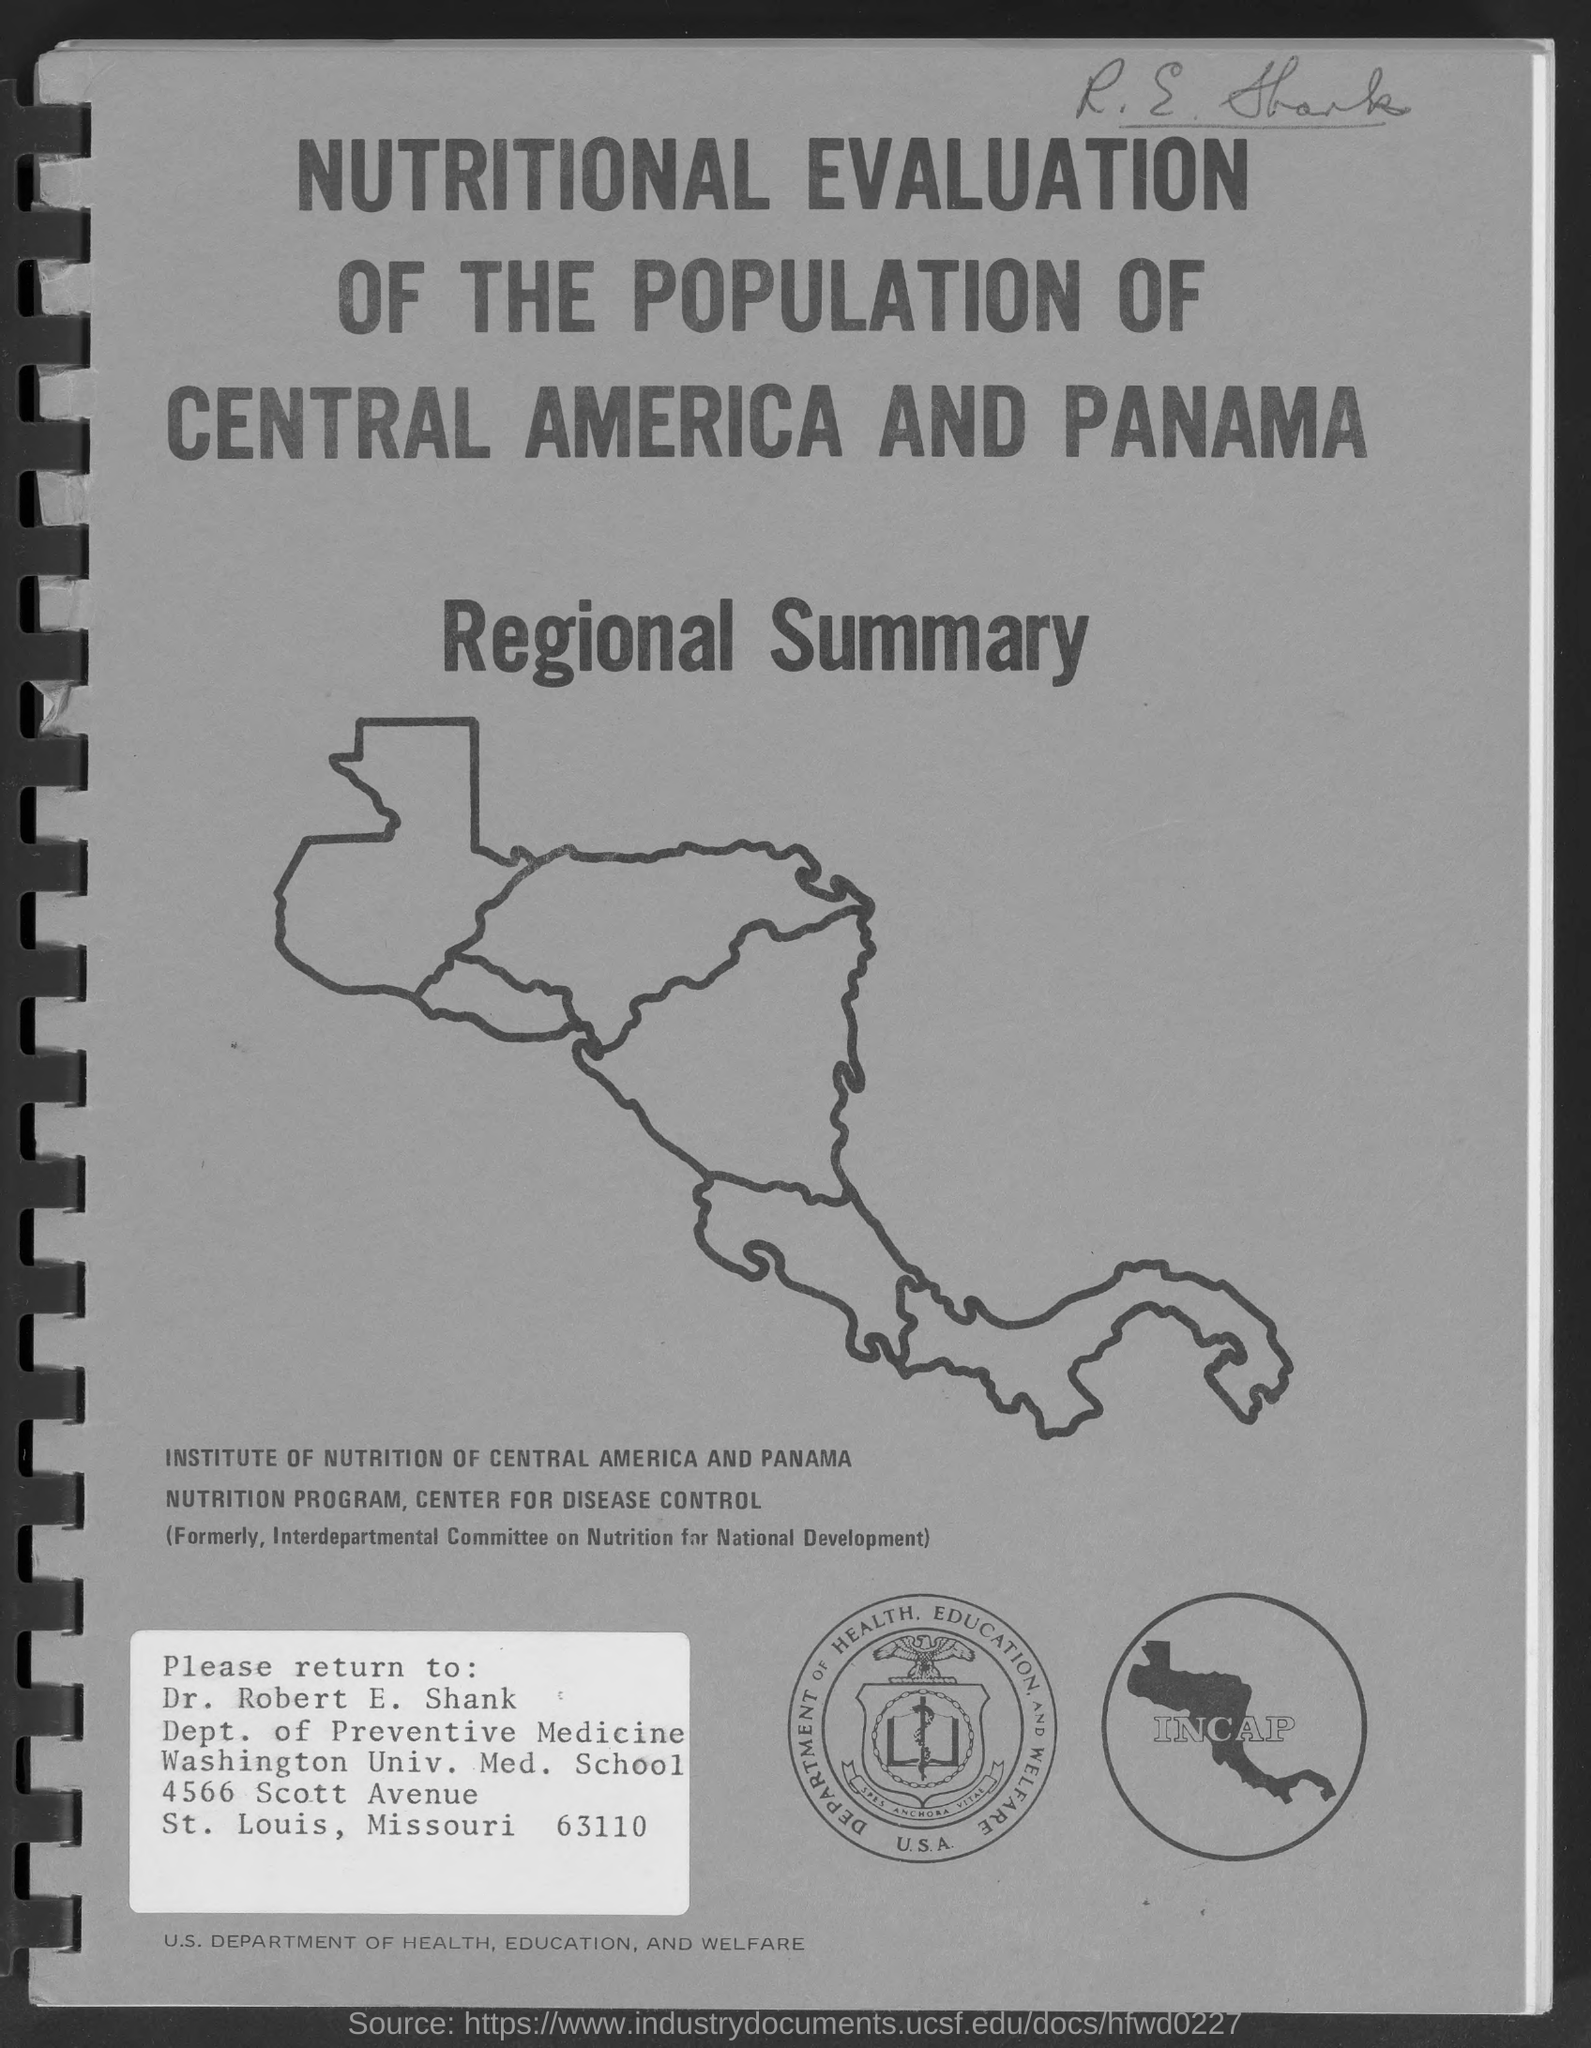What does incap stand for?
Keep it short and to the point. Institute of nutrition of central america and panama. What was institute of nutrition of central america and panama formerly known as?
Provide a succinct answer. Interdepartmental committee on nutrition for national development. To which department does Dr.Robert E. Shank belong to?
Your answer should be compact. Dept. of Preventive Medicine. 